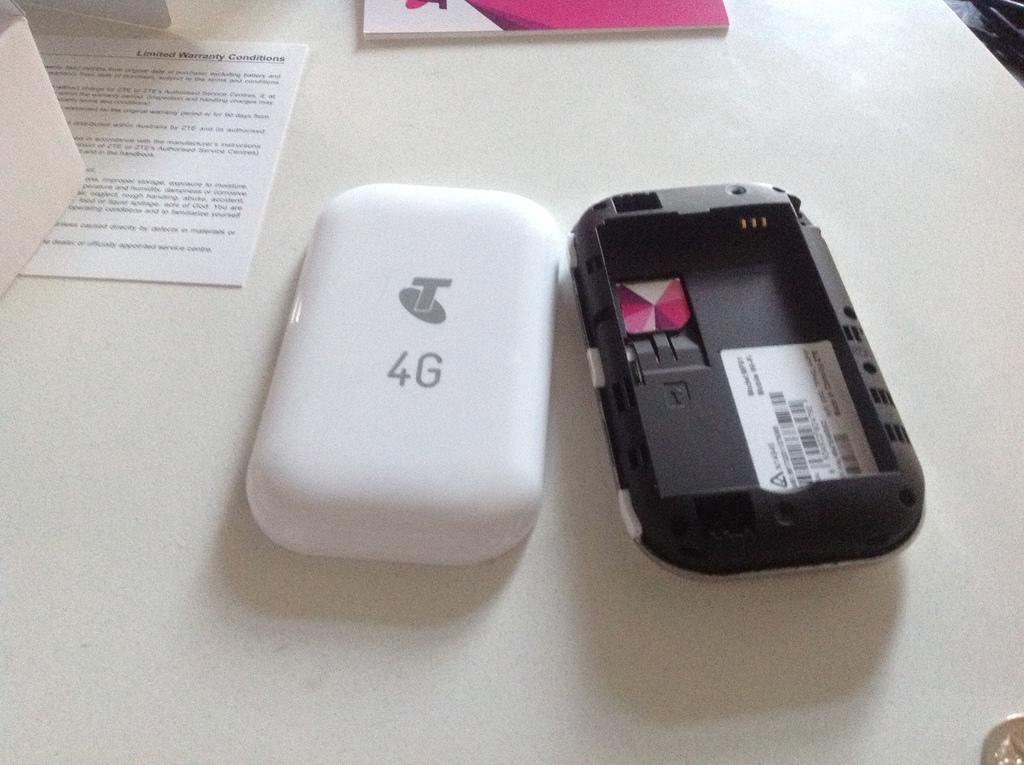<image>
Provide a brief description of the given image. A 4G phone is opened and laying on a table. 